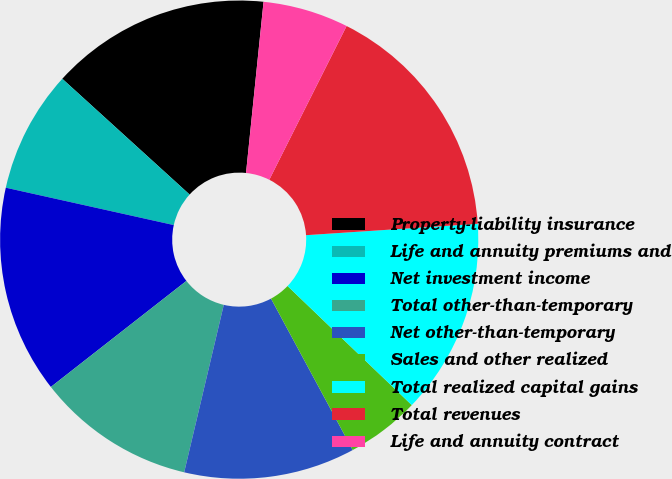Convert chart. <chart><loc_0><loc_0><loc_500><loc_500><pie_chart><fcel>Property-liability insurance<fcel>Life and annuity premiums and<fcel>Net investment income<fcel>Total other-than-temporary<fcel>Net other-than-temporary<fcel>Sales and other realized<fcel>Total realized capital gains<fcel>Total revenues<fcel>Life and annuity contract<nl><fcel>14.88%<fcel>8.26%<fcel>14.05%<fcel>10.74%<fcel>11.57%<fcel>4.96%<fcel>13.22%<fcel>16.53%<fcel>5.79%<nl></chart> 